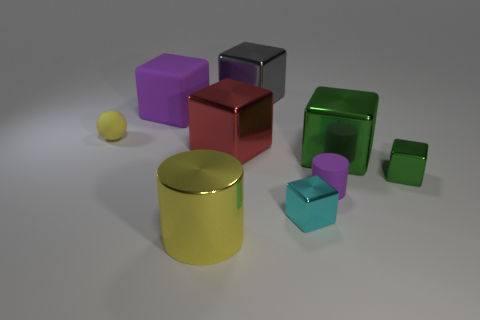Subtract all green balls. How many green cubes are left? 2 Subtract all big gray cubes. How many cubes are left? 5 Subtract all purple cubes. How many cubes are left? 5 Add 1 big rubber blocks. How many objects exist? 10 Subtract all gray blocks. Subtract all gray cylinders. How many blocks are left? 5 Subtract all balls. How many objects are left? 8 Add 7 small red blocks. How many small red blocks exist? 7 Subtract 0 gray balls. How many objects are left? 9 Subtract all small purple things. Subtract all yellow shiny objects. How many objects are left? 7 Add 4 small purple rubber things. How many small purple rubber things are left? 5 